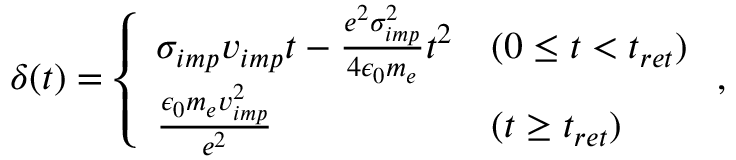Convert formula to latex. <formula><loc_0><loc_0><loc_500><loc_500>\delta ( t ) = \left \{ \begin{array} { l l } { \sigma _ { i m p } v _ { i m p } t - \frac { e ^ { 2 } \sigma _ { i m p } ^ { 2 } } { 4 \epsilon _ { 0 } m _ { e } } t ^ { 2 } } & { ( 0 \leq t < t _ { r e t } ) } \\ { \frac { \epsilon _ { 0 } m _ { e } v _ { i m p } ^ { 2 } } { e ^ { 2 } } } & { ( t \geq t _ { r e t } ) } \end{array} ,</formula> 